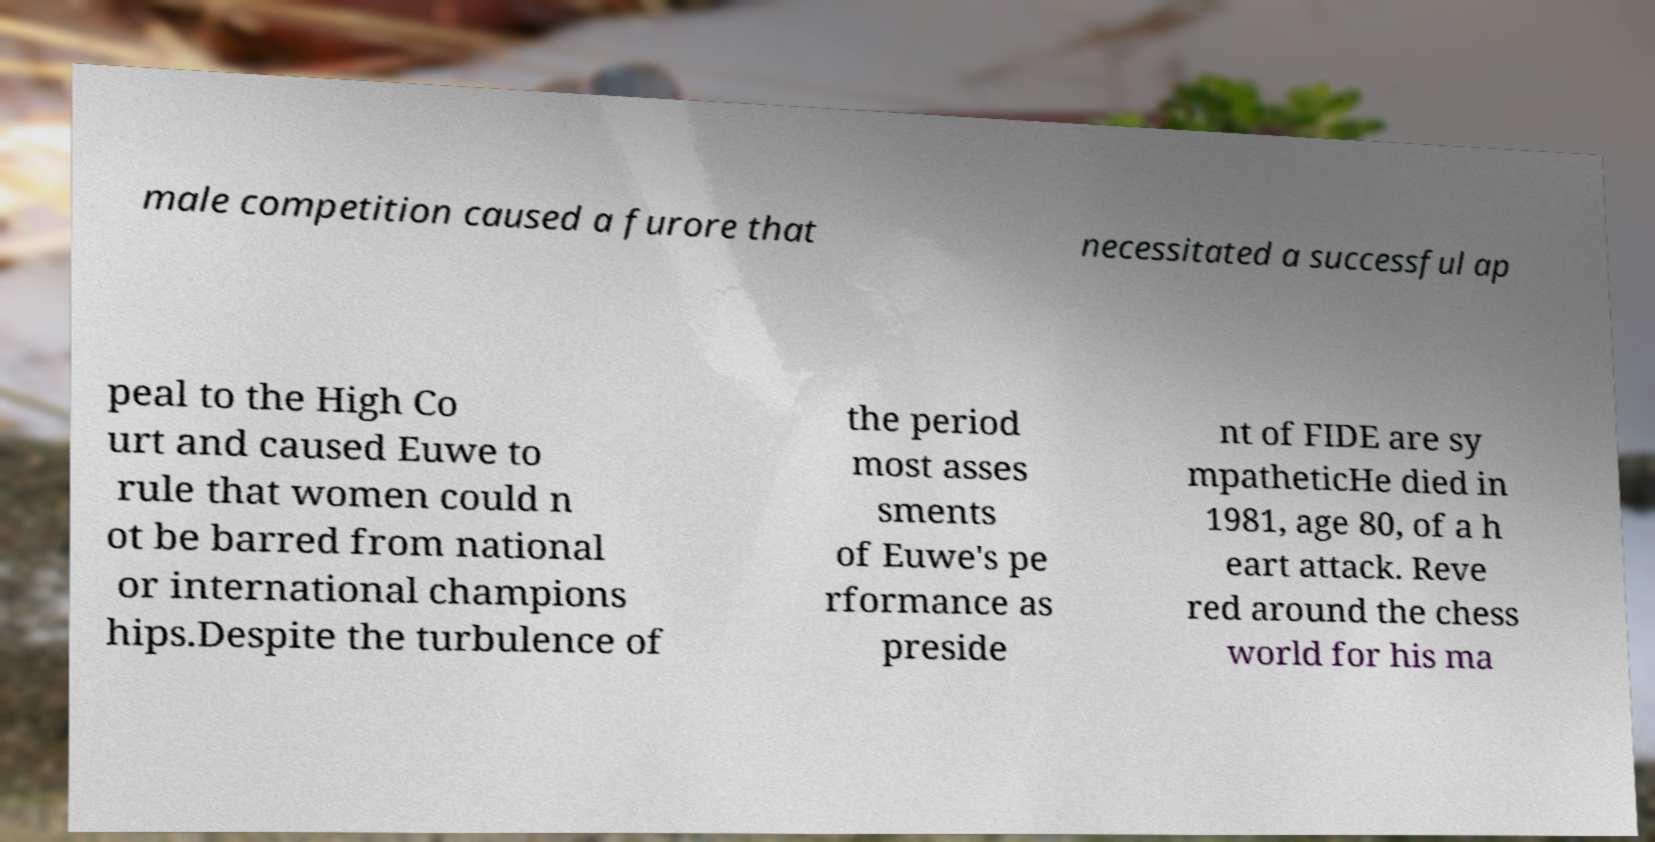Could you extract and type out the text from this image? male competition caused a furore that necessitated a successful ap peal to the High Co urt and caused Euwe to rule that women could n ot be barred from national or international champions hips.Despite the turbulence of the period most asses sments of Euwe's pe rformance as preside nt of FIDE are sy mpatheticHe died in 1981, age 80, of a h eart attack. Reve red around the chess world for his ma 